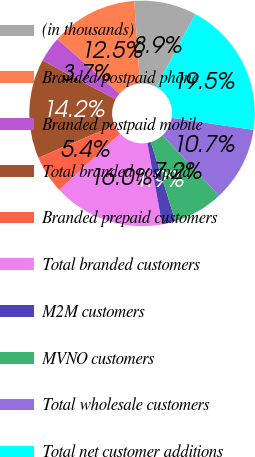Convert chart. <chart><loc_0><loc_0><loc_500><loc_500><pie_chart><fcel>(in thousands)<fcel>Branded postpaid phone<fcel>Branded postpaid mobile<fcel>Total branded postpaid<fcel>Branded prepaid customers<fcel>Total branded customers<fcel>M2M customers<fcel>MVNO customers<fcel>Total wholesale customers<fcel>Total net customer additions<nl><fcel>8.95%<fcel>12.46%<fcel>3.67%<fcel>14.22%<fcel>5.43%<fcel>15.98%<fcel>1.92%<fcel>7.19%<fcel>10.7%<fcel>19.49%<nl></chart> 